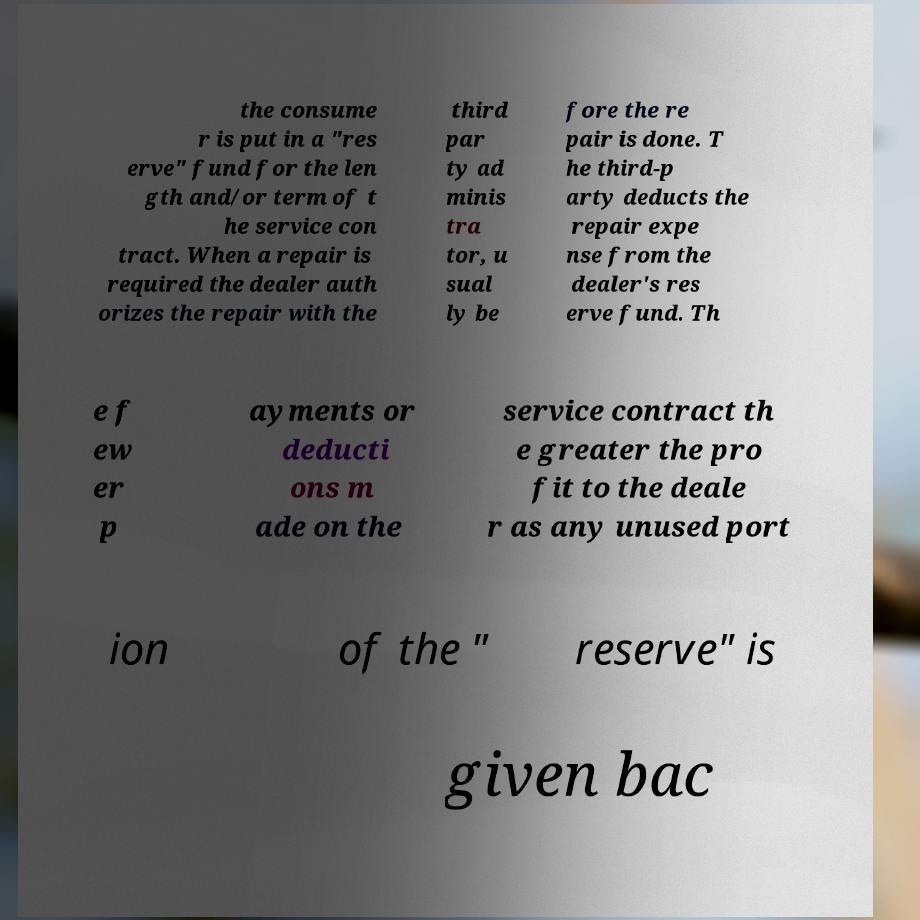Could you assist in decoding the text presented in this image and type it out clearly? the consume r is put in a "res erve" fund for the len gth and/or term of t he service con tract. When a repair is required the dealer auth orizes the repair with the third par ty ad minis tra tor, u sual ly be fore the re pair is done. T he third-p arty deducts the repair expe nse from the dealer's res erve fund. Th e f ew er p ayments or deducti ons m ade on the service contract th e greater the pro fit to the deale r as any unused port ion of the " reserve" is given bac 